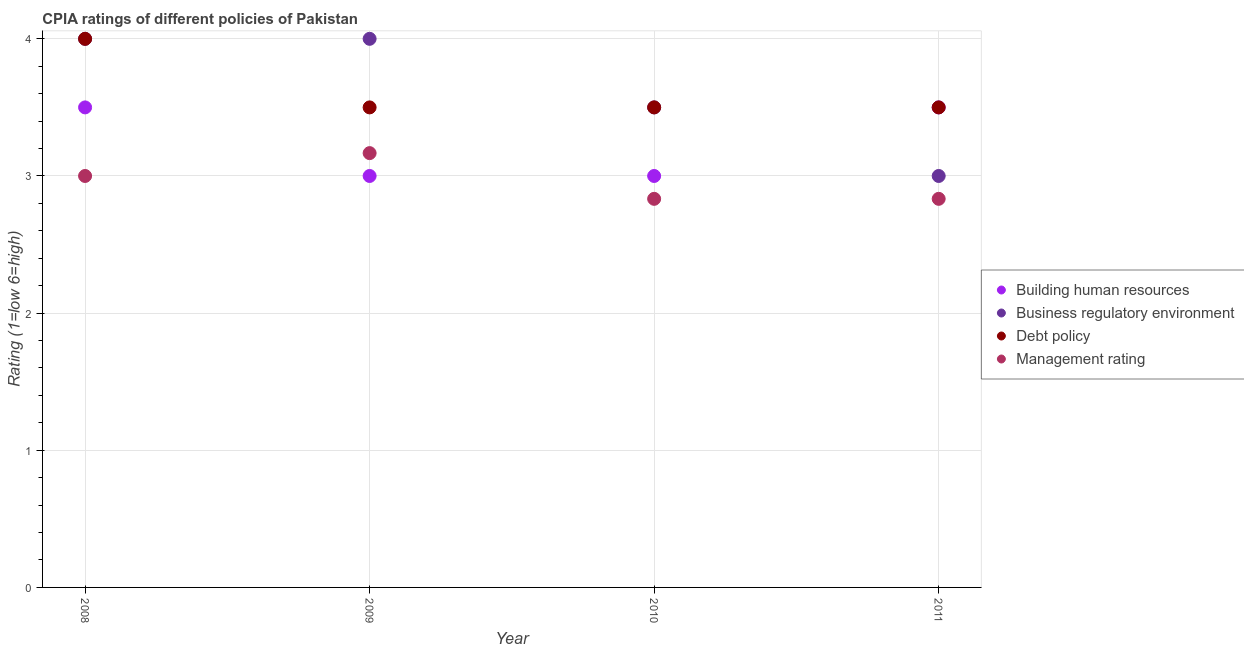Is the number of dotlines equal to the number of legend labels?
Ensure brevity in your answer.  Yes. What is the cpia rating of management in 2009?
Your response must be concise. 3.17. Across all years, what is the minimum cpia rating of management?
Keep it short and to the point. 2.83. What is the total cpia rating of business regulatory environment in the graph?
Give a very brief answer. 14.5. What is the difference between the cpia rating of building human resources in 2008 and that in 2011?
Your answer should be compact. 0. What is the average cpia rating of business regulatory environment per year?
Offer a terse response. 3.62. In the year 2008, what is the difference between the cpia rating of management and cpia rating of building human resources?
Your answer should be compact. -0.5. What is the ratio of the cpia rating of building human resources in 2009 to that in 2011?
Your response must be concise. 0.86. What is the difference between the highest and the second highest cpia rating of building human resources?
Offer a terse response. 0. What is the difference between the highest and the lowest cpia rating of management?
Your response must be concise. 0.33. Is it the case that in every year, the sum of the cpia rating of building human resources and cpia rating of business regulatory environment is greater than the cpia rating of debt policy?
Your response must be concise. Yes. Does the cpia rating of building human resources monotonically increase over the years?
Offer a terse response. No. Is the cpia rating of management strictly less than the cpia rating of building human resources over the years?
Offer a very short reply. No. How many years are there in the graph?
Your answer should be compact. 4. How many legend labels are there?
Give a very brief answer. 4. What is the title of the graph?
Your response must be concise. CPIA ratings of different policies of Pakistan. Does "WFP" appear as one of the legend labels in the graph?
Your response must be concise. No. What is the Rating (1=low 6=high) of Debt policy in 2008?
Make the answer very short. 4. What is the Rating (1=low 6=high) in Management rating in 2008?
Your answer should be very brief. 3. What is the Rating (1=low 6=high) in Management rating in 2009?
Offer a very short reply. 3.17. What is the Rating (1=low 6=high) in Building human resources in 2010?
Offer a terse response. 3. What is the Rating (1=low 6=high) of Business regulatory environment in 2010?
Make the answer very short. 3.5. What is the Rating (1=low 6=high) of Debt policy in 2010?
Offer a very short reply. 3.5. What is the Rating (1=low 6=high) of Management rating in 2010?
Your answer should be very brief. 2.83. What is the Rating (1=low 6=high) in Management rating in 2011?
Offer a very short reply. 2.83. Across all years, what is the maximum Rating (1=low 6=high) of Building human resources?
Your response must be concise. 3.5. Across all years, what is the maximum Rating (1=low 6=high) in Debt policy?
Your answer should be compact. 4. Across all years, what is the maximum Rating (1=low 6=high) in Management rating?
Give a very brief answer. 3.17. Across all years, what is the minimum Rating (1=low 6=high) in Building human resources?
Give a very brief answer. 3. Across all years, what is the minimum Rating (1=low 6=high) of Debt policy?
Your answer should be compact. 3.5. Across all years, what is the minimum Rating (1=low 6=high) in Management rating?
Ensure brevity in your answer.  2.83. What is the total Rating (1=low 6=high) in Debt policy in the graph?
Ensure brevity in your answer.  14.5. What is the total Rating (1=low 6=high) in Management rating in the graph?
Give a very brief answer. 11.83. What is the difference between the Rating (1=low 6=high) of Building human resources in 2008 and that in 2009?
Provide a short and direct response. 0.5. What is the difference between the Rating (1=low 6=high) of Debt policy in 2008 and that in 2009?
Your answer should be very brief. 0.5. What is the difference between the Rating (1=low 6=high) in Management rating in 2008 and that in 2009?
Your response must be concise. -0.17. What is the difference between the Rating (1=low 6=high) in Management rating in 2008 and that in 2010?
Offer a terse response. 0.17. What is the difference between the Rating (1=low 6=high) in Building human resources in 2008 and that in 2011?
Your answer should be very brief. 0. What is the difference between the Rating (1=low 6=high) of Debt policy in 2008 and that in 2011?
Give a very brief answer. 0.5. What is the difference between the Rating (1=low 6=high) in Business regulatory environment in 2009 and that in 2010?
Your response must be concise. 0.5. What is the difference between the Rating (1=low 6=high) of Business regulatory environment in 2009 and that in 2011?
Provide a short and direct response. 1. What is the difference between the Rating (1=low 6=high) in Debt policy in 2009 and that in 2011?
Give a very brief answer. 0. What is the difference between the Rating (1=low 6=high) in Building human resources in 2008 and the Rating (1=low 6=high) in Debt policy in 2009?
Keep it short and to the point. 0. What is the difference between the Rating (1=low 6=high) in Business regulatory environment in 2008 and the Rating (1=low 6=high) in Debt policy in 2009?
Your response must be concise. 0.5. What is the difference between the Rating (1=low 6=high) in Debt policy in 2008 and the Rating (1=low 6=high) in Management rating in 2010?
Your answer should be very brief. 1.17. What is the difference between the Rating (1=low 6=high) of Building human resources in 2008 and the Rating (1=low 6=high) of Business regulatory environment in 2011?
Give a very brief answer. 0.5. What is the difference between the Rating (1=low 6=high) of Business regulatory environment in 2008 and the Rating (1=low 6=high) of Management rating in 2011?
Ensure brevity in your answer.  1.17. What is the difference between the Rating (1=low 6=high) of Business regulatory environment in 2009 and the Rating (1=low 6=high) of Debt policy in 2010?
Make the answer very short. 0.5. What is the difference between the Rating (1=low 6=high) in Business regulatory environment in 2009 and the Rating (1=low 6=high) in Management rating in 2010?
Your response must be concise. 1.17. What is the difference between the Rating (1=low 6=high) in Debt policy in 2009 and the Rating (1=low 6=high) in Management rating in 2010?
Make the answer very short. 0.67. What is the difference between the Rating (1=low 6=high) in Building human resources in 2009 and the Rating (1=low 6=high) in Business regulatory environment in 2011?
Provide a short and direct response. 0. What is the difference between the Rating (1=low 6=high) in Business regulatory environment in 2009 and the Rating (1=low 6=high) in Management rating in 2011?
Offer a very short reply. 1.17. What is the difference between the Rating (1=low 6=high) in Debt policy in 2009 and the Rating (1=low 6=high) in Management rating in 2011?
Your response must be concise. 0.67. What is the difference between the Rating (1=low 6=high) of Business regulatory environment in 2010 and the Rating (1=low 6=high) of Debt policy in 2011?
Offer a terse response. 0. What is the difference between the Rating (1=low 6=high) of Business regulatory environment in 2010 and the Rating (1=low 6=high) of Management rating in 2011?
Offer a very short reply. 0.67. What is the average Rating (1=low 6=high) in Building human resources per year?
Make the answer very short. 3.25. What is the average Rating (1=low 6=high) in Business regulatory environment per year?
Provide a succinct answer. 3.62. What is the average Rating (1=low 6=high) in Debt policy per year?
Your response must be concise. 3.62. What is the average Rating (1=low 6=high) of Management rating per year?
Your response must be concise. 2.96. In the year 2008, what is the difference between the Rating (1=low 6=high) in Building human resources and Rating (1=low 6=high) in Business regulatory environment?
Your answer should be compact. -0.5. In the year 2008, what is the difference between the Rating (1=low 6=high) in Building human resources and Rating (1=low 6=high) in Debt policy?
Provide a short and direct response. -0.5. In the year 2008, what is the difference between the Rating (1=low 6=high) of Business regulatory environment and Rating (1=low 6=high) of Debt policy?
Your answer should be very brief. 0. In the year 2009, what is the difference between the Rating (1=low 6=high) of Building human resources and Rating (1=low 6=high) of Management rating?
Keep it short and to the point. -0.17. In the year 2009, what is the difference between the Rating (1=low 6=high) in Business regulatory environment and Rating (1=low 6=high) in Debt policy?
Offer a very short reply. 0.5. In the year 2010, what is the difference between the Rating (1=low 6=high) in Building human resources and Rating (1=low 6=high) in Business regulatory environment?
Your answer should be very brief. -0.5. In the year 2010, what is the difference between the Rating (1=low 6=high) in Building human resources and Rating (1=low 6=high) in Debt policy?
Your response must be concise. -0.5. In the year 2011, what is the difference between the Rating (1=low 6=high) in Business regulatory environment and Rating (1=low 6=high) in Debt policy?
Provide a short and direct response. -0.5. In the year 2011, what is the difference between the Rating (1=low 6=high) in Debt policy and Rating (1=low 6=high) in Management rating?
Ensure brevity in your answer.  0.67. What is the ratio of the Rating (1=low 6=high) in Debt policy in 2008 to that in 2009?
Make the answer very short. 1.14. What is the ratio of the Rating (1=low 6=high) of Business regulatory environment in 2008 to that in 2010?
Give a very brief answer. 1.14. What is the ratio of the Rating (1=low 6=high) in Debt policy in 2008 to that in 2010?
Your response must be concise. 1.14. What is the ratio of the Rating (1=low 6=high) in Management rating in 2008 to that in 2010?
Your answer should be compact. 1.06. What is the ratio of the Rating (1=low 6=high) of Management rating in 2008 to that in 2011?
Offer a terse response. 1.06. What is the ratio of the Rating (1=low 6=high) in Building human resources in 2009 to that in 2010?
Offer a terse response. 1. What is the ratio of the Rating (1=low 6=high) in Management rating in 2009 to that in 2010?
Your answer should be compact. 1.12. What is the ratio of the Rating (1=low 6=high) of Building human resources in 2009 to that in 2011?
Offer a terse response. 0.86. What is the ratio of the Rating (1=low 6=high) in Business regulatory environment in 2009 to that in 2011?
Your response must be concise. 1.33. What is the ratio of the Rating (1=low 6=high) of Management rating in 2009 to that in 2011?
Make the answer very short. 1.12. What is the ratio of the Rating (1=low 6=high) of Debt policy in 2010 to that in 2011?
Make the answer very short. 1. What is the ratio of the Rating (1=low 6=high) in Management rating in 2010 to that in 2011?
Provide a short and direct response. 1. What is the difference between the highest and the second highest Rating (1=low 6=high) of Debt policy?
Your answer should be compact. 0.5. What is the difference between the highest and the second highest Rating (1=low 6=high) of Management rating?
Ensure brevity in your answer.  0.17. What is the difference between the highest and the lowest Rating (1=low 6=high) of Debt policy?
Offer a very short reply. 0.5. What is the difference between the highest and the lowest Rating (1=low 6=high) in Management rating?
Provide a succinct answer. 0.33. 